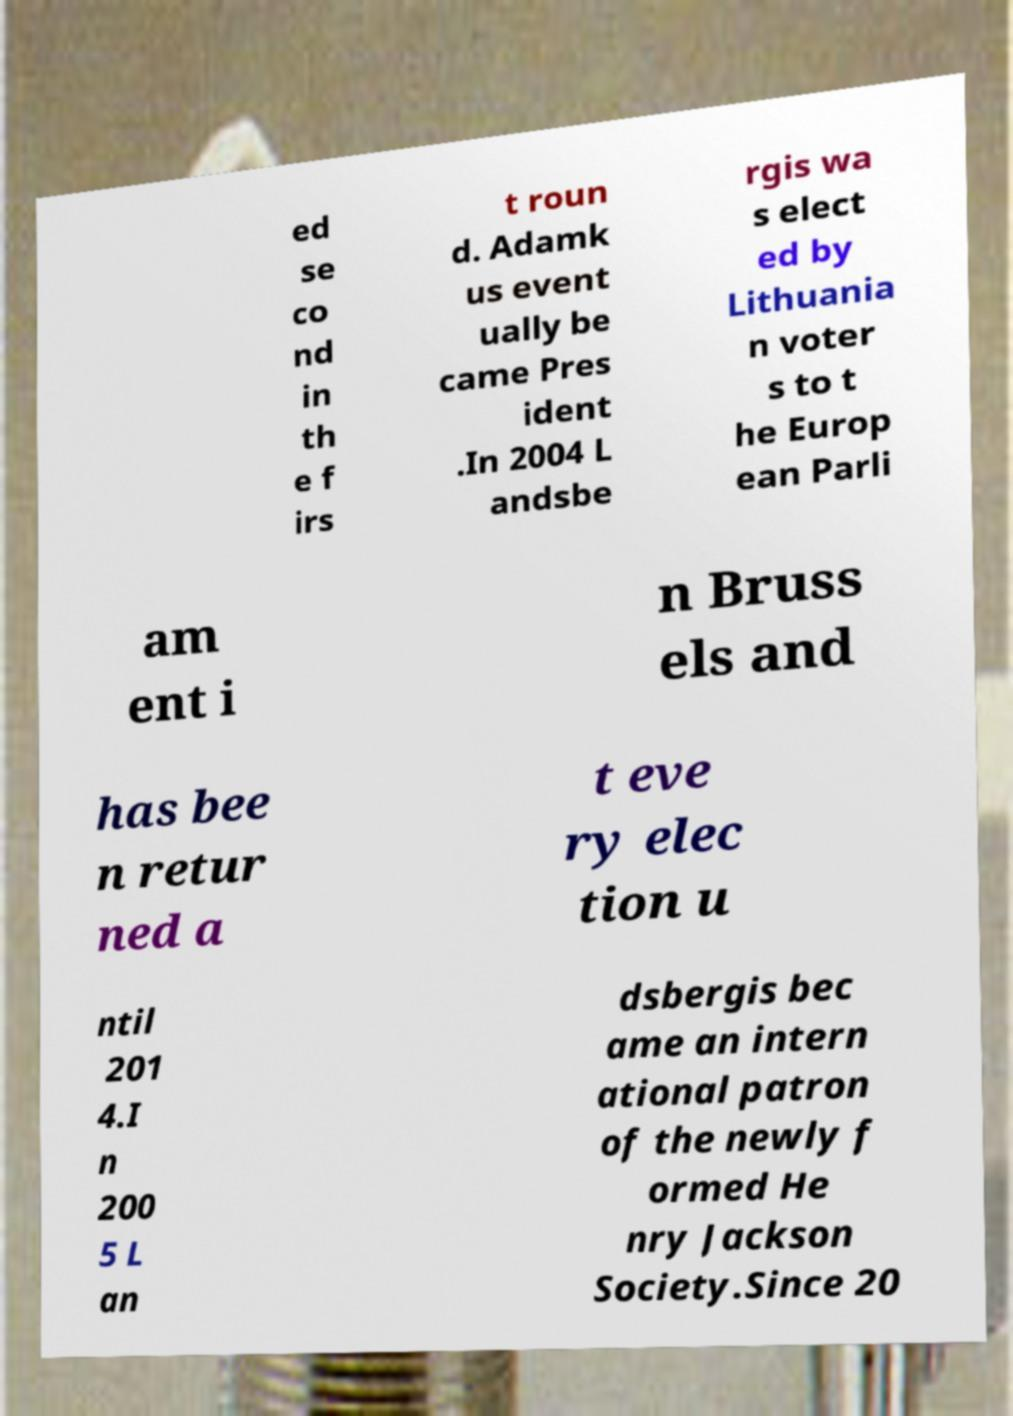For documentation purposes, I need the text within this image transcribed. Could you provide that? ed se co nd in th e f irs t roun d. Adamk us event ually be came Pres ident .In 2004 L andsbe rgis wa s elect ed by Lithuania n voter s to t he Europ ean Parli am ent i n Bruss els and has bee n retur ned a t eve ry elec tion u ntil 201 4.I n 200 5 L an dsbergis bec ame an intern ational patron of the newly f ormed He nry Jackson Society.Since 20 